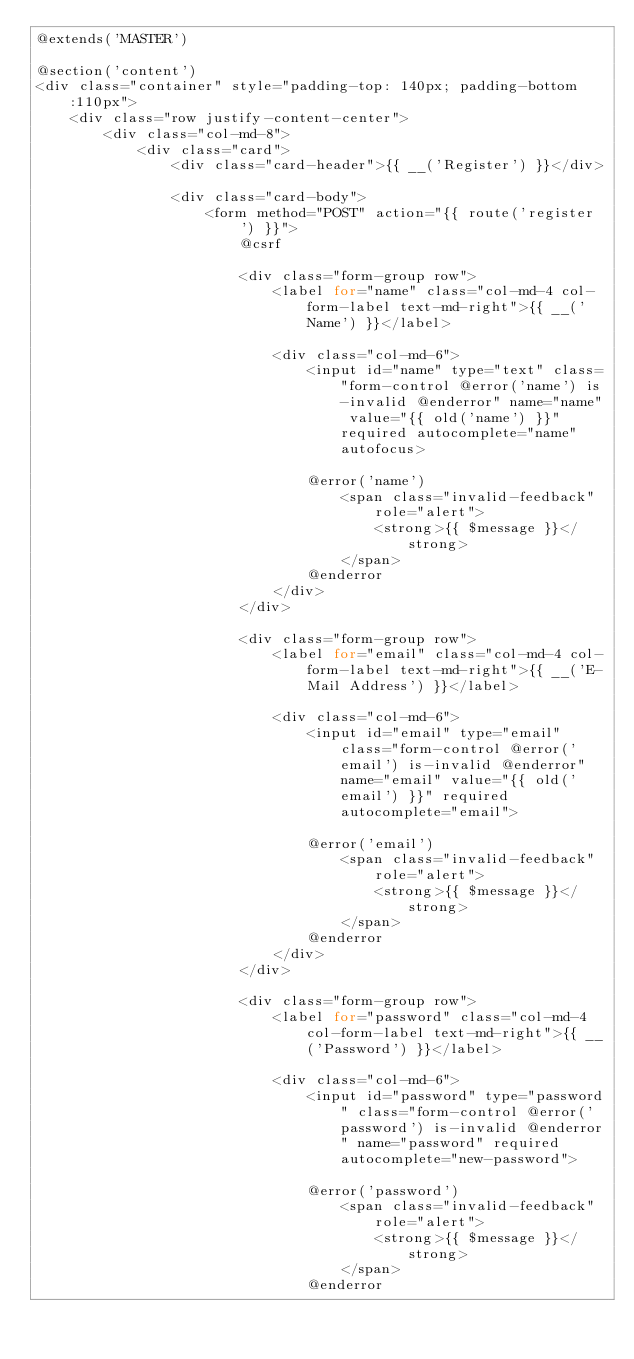<code> <loc_0><loc_0><loc_500><loc_500><_PHP_>@extends('MASTER')

@section('content')
<div class="container" style="padding-top: 140px; padding-bottom:110px">
    <div class="row justify-content-center">
        <div class="col-md-8">
            <div class="card">
                <div class="card-header">{{ __('Register') }}</div>

                <div class="card-body">
                    <form method="POST" action="{{ route('register') }}">
                        @csrf

                        <div class="form-group row">
                            <label for="name" class="col-md-4 col-form-label text-md-right">{{ __('Name') }}</label>

                            <div class="col-md-6">
                                <input id="name" type="text" class="form-control @error('name') is-invalid @enderror" name="name" value="{{ old('name') }}" required autocomplete="name" autofocus>

                                @error('name')
                                    <span class="invalid-feedback" role="alert">
                                        <strong>{{ $message }}</strong>
                                    </span>
                                @enderror
                            </div>
                        </div>

                        <div class="form-group row">
                            <label for="email" class="col-md-4 col-form-label text-md-right">{{ __('E-Mail Address') }}</label>

                            <div class="col-md-6">
                                <input id="email" type="email" class="form-control @error('email') is-invalid @enderror" name="email" value="{{ old('email') }}" required autocomplete="email">

                                @error('email')
                                    <span class="invalid-feedback" role="alert">
                                        <strong>{{ $message }}</strong>
                                    </span>
                                @enderror
                            </div>
                        </div>

                        <div class="form-group row">
                            <label for="password" class="col-md-4 col-form-label text-md-right">{{ __('Password') }}</label>

                            <div class="col-md-6">
                                <input id="password" type="password" class="form-control @error('password') is-invalid @enderror" name="password" required autocomplete="new-password">

                                @error('password')
                                    <span class="invalid-feedback" role="alert">
                                        <strong>{{ $message }}</strong>
                                    </span>
                                @enderror</code> 